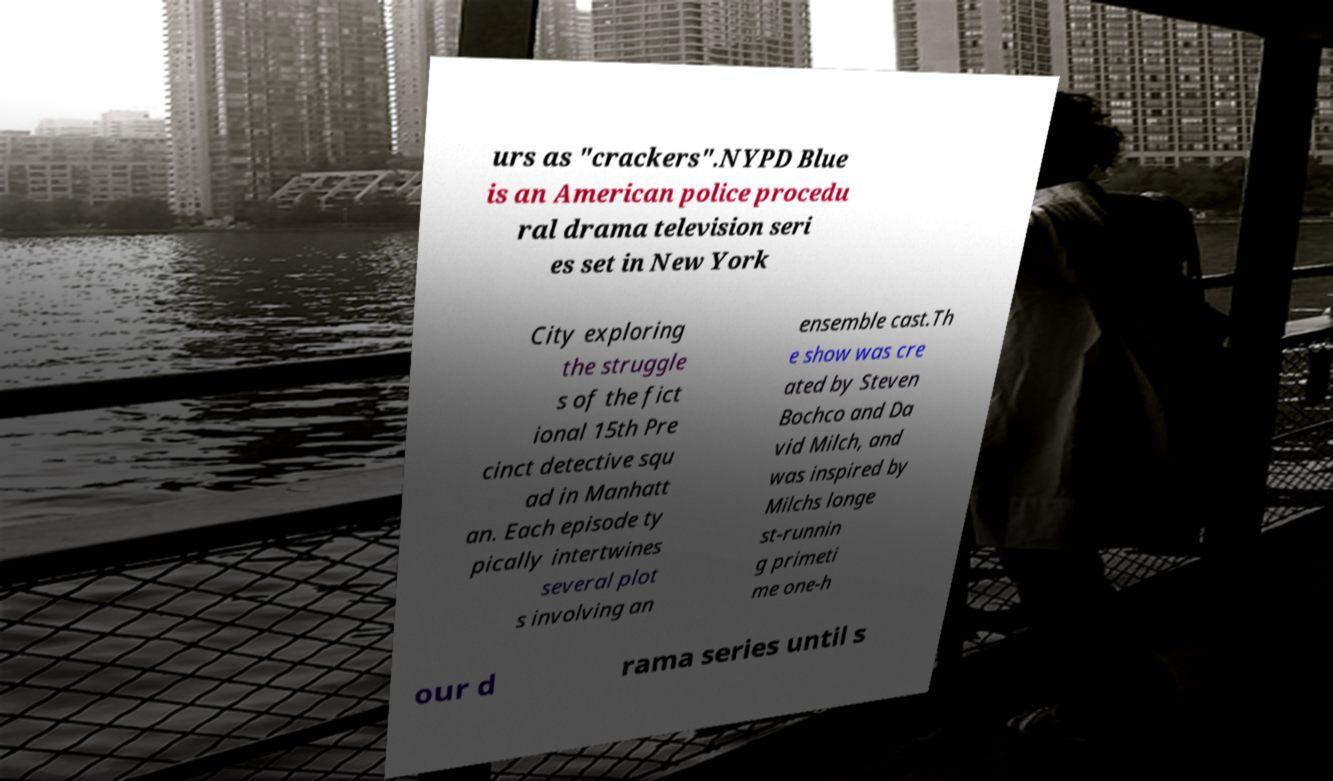Can you accurately transcribe the text from the provided image for me? urs as "crackers".NYPD Blue is an American police procedu ral drama television seri es set in New York City exploring the struggle s of the fict ional 15th Pre cinct detective squ ad in Manhatt an. Each episode ty pically intertwines several plot s involving an ensemble cast.Th e show was cre ated by Steven Bochco and Da vid Milch, and was inspired by Milchs longe st-runnin g primeti me one-h our d rama series until s 